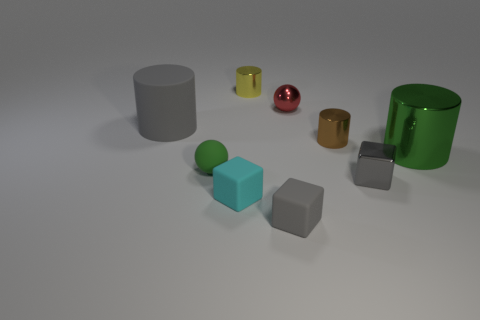Subtract all cyan balls. Subtract all red cubes. How many balls are left? 2 Subtract all blocks. How many objects are left? 6 Subtract all gray objects. Subtract all large cyan cylinders. How many objects are left? 6 Add 4 tiny cyan matte objects. How many tiny cyan matte objects are left? 5 Add 5 blue matte cylinders. How many blue matte cylinders exist? 5 Subtract 0 cyan spheres. How many objects are left? 9 